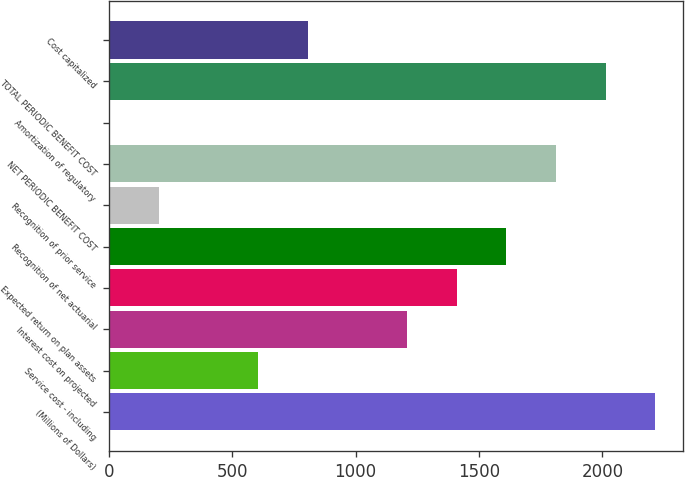<chart> <loc_0><loc_0><loc_500><loc_500><bar_chart><fcel>(Millions of Dollars)<fcel>Service cost - including<fcel>Interest cost on projected<fcel>Expected return on plan assets<fcel>Recognition of net actuarial<fcel>Recognition of prior service<fcel>NET PERIODIC BENEFIT COST<fcel>Amortization of regulatory<fcel>TOTAL PERIODIC BENEFIT COST<fcel>Cost capitalized<nl><fcel>2214.1<fcel>605.3<fcel>1208.6<fcel>1409.7<fcel>1610.8<fcel>203.1<fcel>1811.9<fcel>2<fcel>2013<fcel>806.4<nl></chart> 